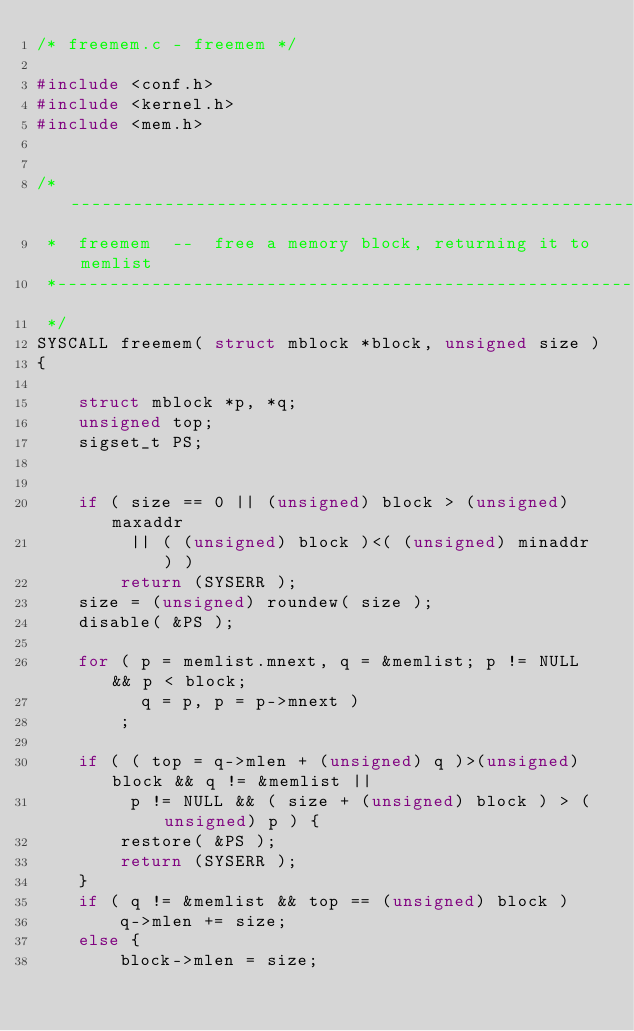Convert code to text. <code><loc_0><loc_0><loc_500><loc_500><_C_>/* freemem.c - freemem */

#include <conf.h>
#include <kernel.h>
#include <mem.h>


/*------------------------------------------------------------------------
 *  freemem  --  free a memory block, returning it to memlist
 *------------------------------------------------------------------------
 */
SYSCALL freemem( struct mblock *block, unsigned size )
{

    struct mblock *p, *q;
    unsigned top;
    sigset_t PS;


    if ( size == 0 || (unsigned) block > (unsigned) maxaddr
         || ( (unsigned) block )<( (unsigned) minaddr ) )
        return (SYSERR );
    size = (unsigned) roundew( size );
    disable( &PS );

    for ( p = memlist.mnext, q = &memlist; p != NULL && p < block;
          q = p, p = p->mnext )
        ;

    if ( ( top = q->mlen + (unsigned) q )>(unsigned) block && q != &memlist ||
         p != NULL && ( size + (unsigned) block ) > (unsigned) p ) {
        restore( &PS );
        return (SYSERR );
    }
    if ( q != &memlist && top == (unsigned) block )
        q->mlen += size;
    else {
        block->mlen = size;</code> 